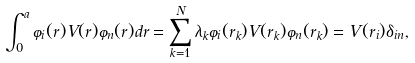Convert formula to latex. <formula><loc_0><loc_0><loc_500><loc_500>\int _ { 0 } ^ { a } \varphi _ { i } ( r ) V ( r ) \varphi _ { n } ( r ) d r = \sum _ { k = 1 } ^ { N } \lambda _ { k } \varphi _ { i } ( r _ { k } ) V ( r _ { k } ) \varphi _ { n } ( r _ { k } ) = V ( r _ { i } ) \delta _ { i n } ,</formula> 